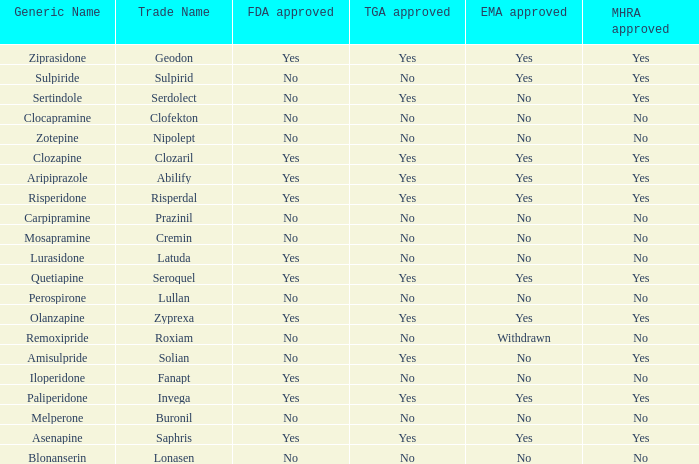Could you parse the entire table? {'header': ['Generic Name', 'Trade Name', 'FDA approved', 'TGA approved', 'EMA approved', 'MHRA approved'], 'rows': [['Ziprasidone', 'Geodon', 'Yes', 'Yes', 'Yes', 'Yes'], ['Sulpiride', 'Sulpirid', 'No', 'No', 'Yes', 'Yes'], ['Sertindole', 'Serdolect', 'No', 'Yes', 'No', 'Yes'], ['Clocapramine', 'Clofekton', 'No', 'No', 'No', 'No'], ['Zotepine', 'Nipolept', 'No', 'No', 'No', 'No'], ['Clozapine', 'Clozaril', 'Yes', 'Yes', 'Yes', 'Yes'], ['Aripiprazole', 'Abilify', 'Yes', 'Yes', 'Yes', 'Yes'], ['Risperidone', 'Risperdal', 'Yes', 'Yes', 'Yes', 'Yes'], ['Carpipramine', 'Prazinil', 'No', 'No', 'No', 'No'], ['Mosapramine', 'Cremin', 'No', 'No', 'No', 'No'], ['Lurasidone', 'Latuda', 'Yes', 'No', 'No', 'No'], ['Quetiapine', 'Seroquel', 'Yes', 'Yes', 'Yes', 'Yes'], ['Perospirone', 'Lullan', 'No', 'No', 'No', 'No'], ['Olanzapine', 'Zyprexa', 'Yes', 'Yes', 'Yes', 'Yes'], ['Remoxipride', 'Roxiam', 'No', 'No', 'Withdrawn', 'No'], ['Amisulpride', 'Solian', 'No', 'Yes', 'No', 'Yes'], ['Iloperidone', 'Fanapt', 'Yes', 'No', 'No', 'No'], ['Paliperidone', 'Invega', 'Yes', 'Yes', 'Yes', 'Yes'], ['Melperone', 'Buronil', 'No', 'No', 'No', 'No'], ['Asenapine', 'Saphris', 'Yes', 'Yes', 'Yes', 'Yes'], ['Blonanserin', 'Lonasen', 'No', 'No', 'No', 'No']]} Is Blonanserin MHRA approved? No. 